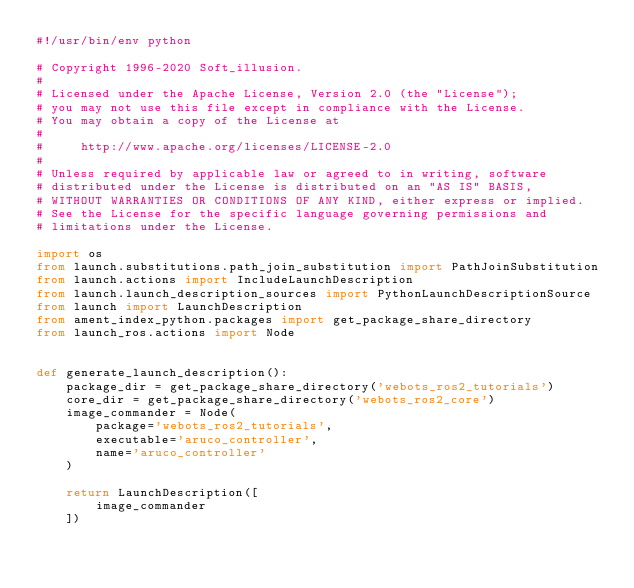Convert code to text. <code><loc_0><loc_0><loc_500><loc_500><_Python_>#!/usr/bin/env python

# Copyright 1996-2020 Soft_illusion.
#
# Licensed under the Apache License, Version 2.0 (the "License");
# you may not use this file except in compliance with the License.
# You may obtain a copy of the License at
#
#     http://www.apache.org/licenses/LICENSE-2.0
#
# Unless required by applicable law or agreed to in writing, software
# distributed under the License is distributed on an "AS IS" BASIS,
# WITHOUT WARRANTIES OR CONDITIONS OF ANY KIND, either express or implied.
# See the License for the specific language governing permissions and
# limitations under the License.

import os
from launch.substitutions.path_join_substitution import PathJoinSubstitution
from launch.actions import IncludeLaunchDescription
from launch.launch_description_sources import PythonLaunchDescriptionSource
from launch import LaunchDescription
from ament_index_python.packages import get_package_share_directory
from launch_ros.actions import Node


def generate_launch_description():
    package_dir = get_package_share_directory('webots_ros2_tutorials')
    core_dir = get_package_share_directory('webots_ros2_core')
    image_commander = Node(
        package='webots_ros2_tutorials',
        executable='aruco_controller',
        name='aruco_controller'
    )

    return LaunchDescription([
        image_commander
    ])
</code> 